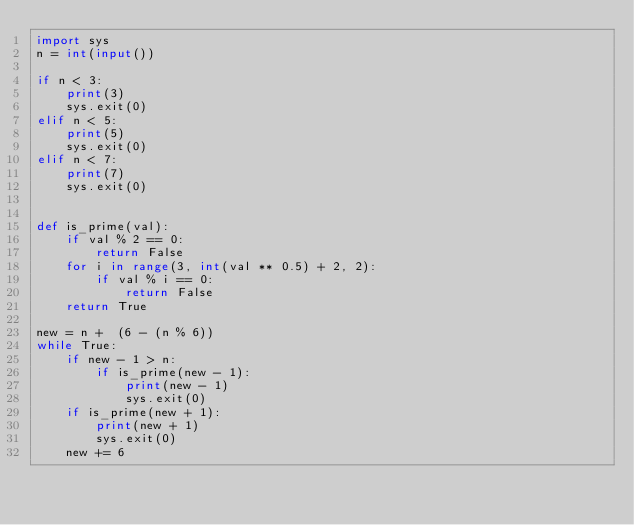Convert code to text. <code><loc_0><loc_0><loc_500><loc_500><_Python_>import sys
n = int(input())

if n < 3:
    print(3)
    sys.exit(0)
elif n < 5:
    print(5)
    sys.exit(0)
elif n < 7:
    print(7)
    sys.exit(0)


def is_prime(val):
    if val % 2 == 0:
        return False
    for i in range(3, int(val ** 0.5) + 2, 2):
        if val % i == 0:
            return False
    return True

new = n +  (6 - (n % 6))
while True:
    if new - 1 > n:
        if is_prime(new - 1):
            print(new - 1)
            sys.exit(0)
    if is_prime(new + 1):
        print(new + 1)
        sys.exit(0)
    new += 6


</code> 